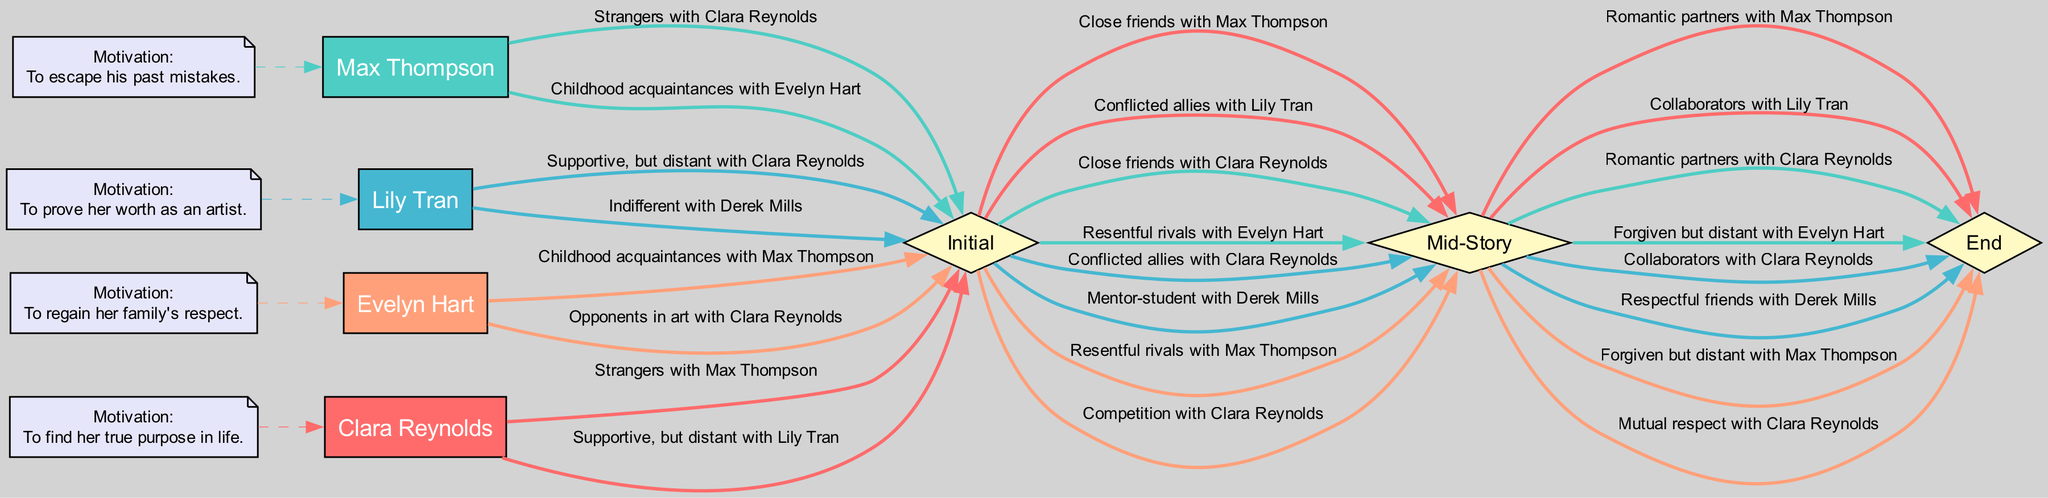What is Clara Reynolds' initial motivation? Clara Reynolds' initial motivation as represented in the diagram is clearly labeled next to her name, which states: "To find her true purpose in life."
Answer: To find her true purpose in life How does Clara's relationship with Max Thompson evolve? The diagram shows three stages of Clara's relationship with Max Thompson: it starts as "Strangers," evolves to "Close friends" in the mid-story, and finally becomes "Romantic partners" at the end.
Answer: Romantic partners What is the end status of Evelyn Hart's relationship with Max Thompson? Following the path from Max Thompson through the different evolution stages, we see that the end status of his relationship with Evelyn Hart is labeled as "Forgiven but distant."
Answer: Forgiven but distant How many characters are involved in the analysis? The diagram lists four characters: Clara Reynolds, Max Thompson, Lily Tran, and Evelyn Hart, which are visually represented with their distinct nodes.
Answer: Four In the mid-story, what is Lily Tran's relationship status with Derek Mills? The mid-story relationship status shows a direct connection that evolves from "Indifferent" to "Mentor-student" indicating Lily Tran's mentoring role, but the focus here is on the mid-story which states "Mentor-student."
Answer: Mentor-student Which character has a relationship labeled as "Supportive, but distant" in the initial status? By examining the relationships, Clara Reynolds' initial relationship status with Lily Tran is labeled as "Supportive, but distant," indicating her initial perception of Lily.
Answer: Supportive, but distant What color is used to represent Max Thompson in the diagram? Each character is represented with a unique color, and Max Thompson's node is colored with the specified color, which is '#4ECDC4'.
Answer: #4ECDC4 What is the status of Clara Reynolds' relationship with Evelyn Hart at the end? Analyzing the pathways, it is evident that Clara Reynolds' relationship with Evelyn Hart evolves to "Mutual respect" at the end, illustrating their development over the story.
Answer: Mutual respect What do the diamond-shaped nodes represent in the diagram? The diamond-shaped nodes labeled "Initial," "Mid-Story," and "End" signify the different stages of relationship evolution for the characters as they progress through the narrative.
Answer: Relationship evolution stages 